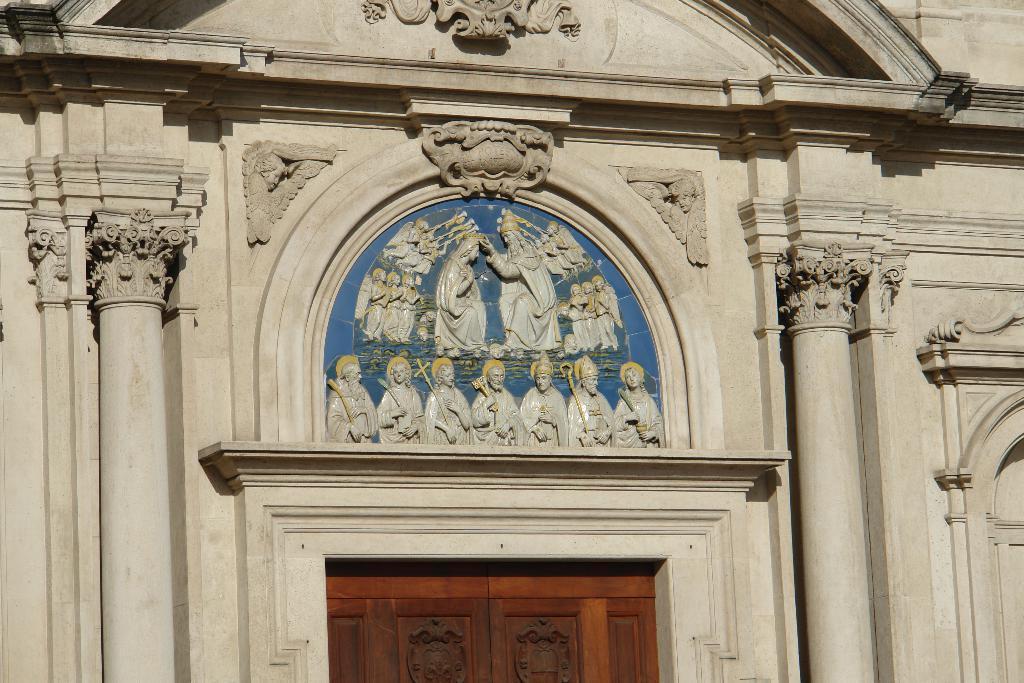In one or two sentences, can you explain what this image depicts? In this image there are carvings, sculptures and pillars for a wall, below the sculptures there is a door. 